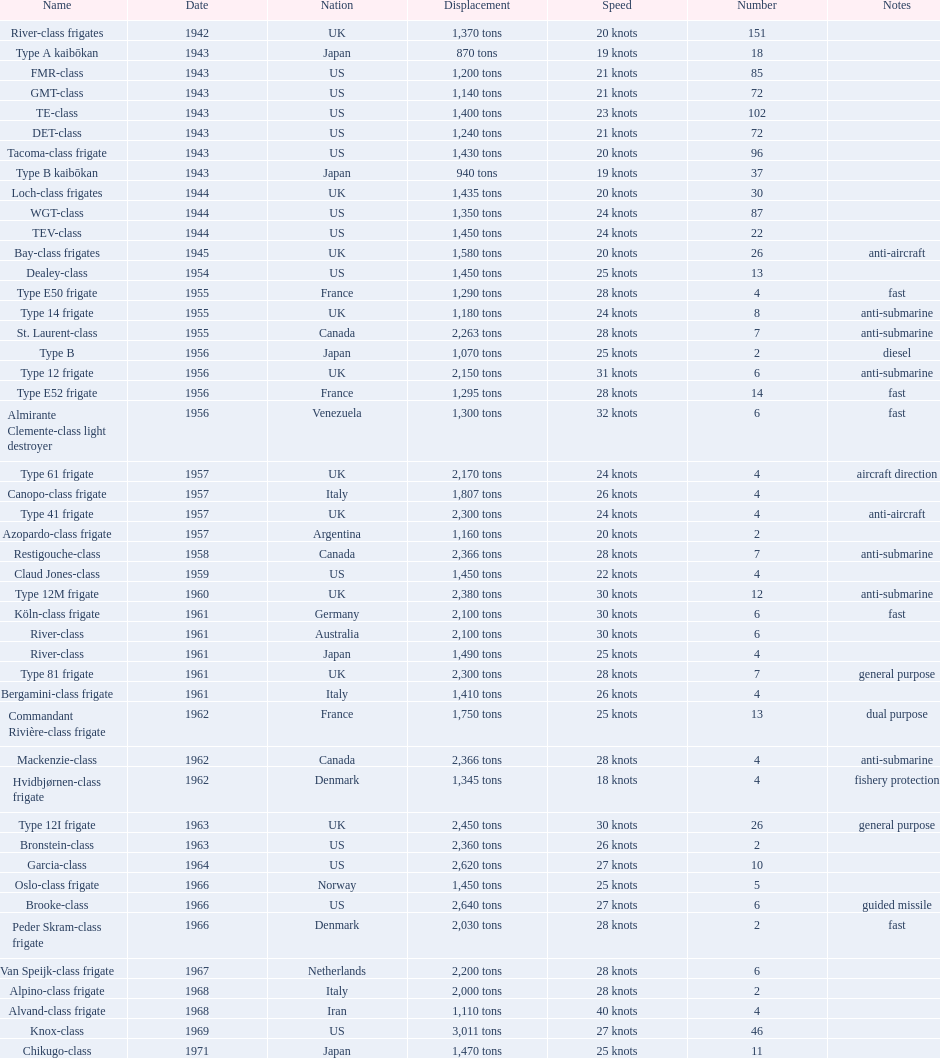What is the top speed? 40 knots. 